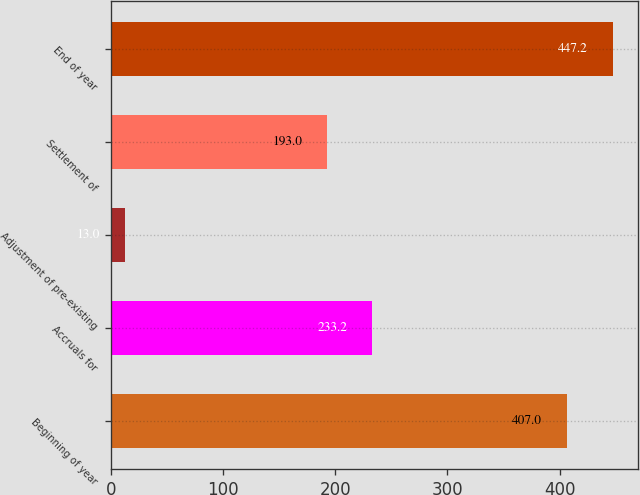Convert chart to OTSL. <chart><loc_0><loc_0><loc_500><loc_500><bar_chart><fcel>Beginning of year<fcel>Accruals for<fcel>Adjustment of pre-existing<fcel>Settlement of<fcel>End of year<nl><fcel>407<fcel>233.2<fcel>13<fcel>193<fcel>447.2<nl></chart> 